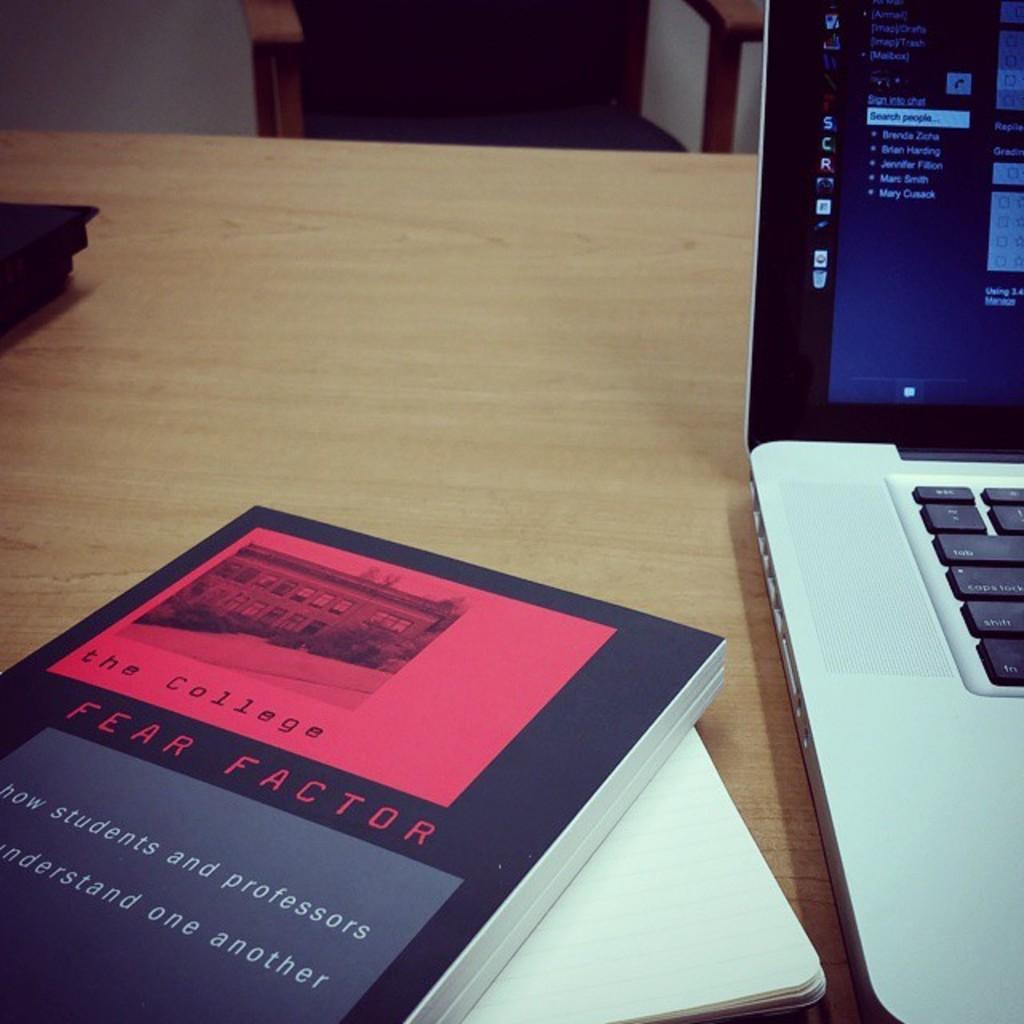<image>
Write a terse but informative summary of the picture. A picture of a desk with a book called the college fear factor, and a laptop on it. 